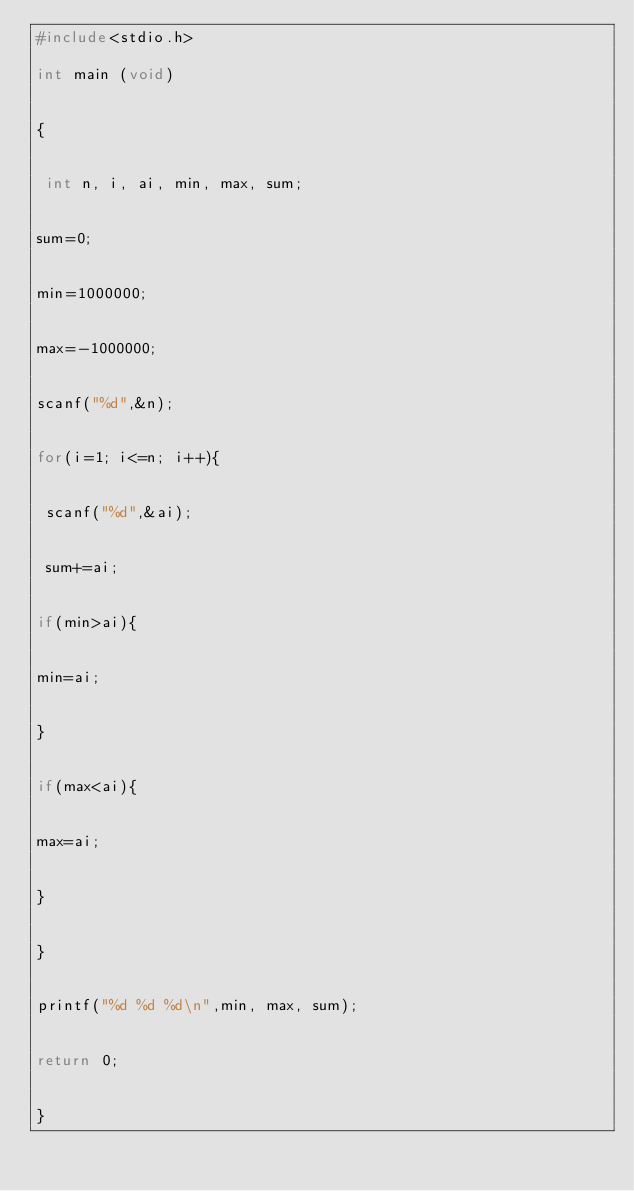Convert code to text. <code><loc_0><loc_0><loc_500><loc_500><_C_>#include<stdio.h>

int main (void)


{


 int n, i, ai, min, max, sum;


sum=0;


min=1000000;


max=-1000000;


scanf("%d",&n);


for(i=1; i<=n; i++){


 scanf("%d",&ai);


 sum+=ai;


if(min>ai){


min=ai;


}


if(max<ai){


max=ai;


}


}


printf("%d %d %d\n",min, max, sum);


return 0;


}</code> 